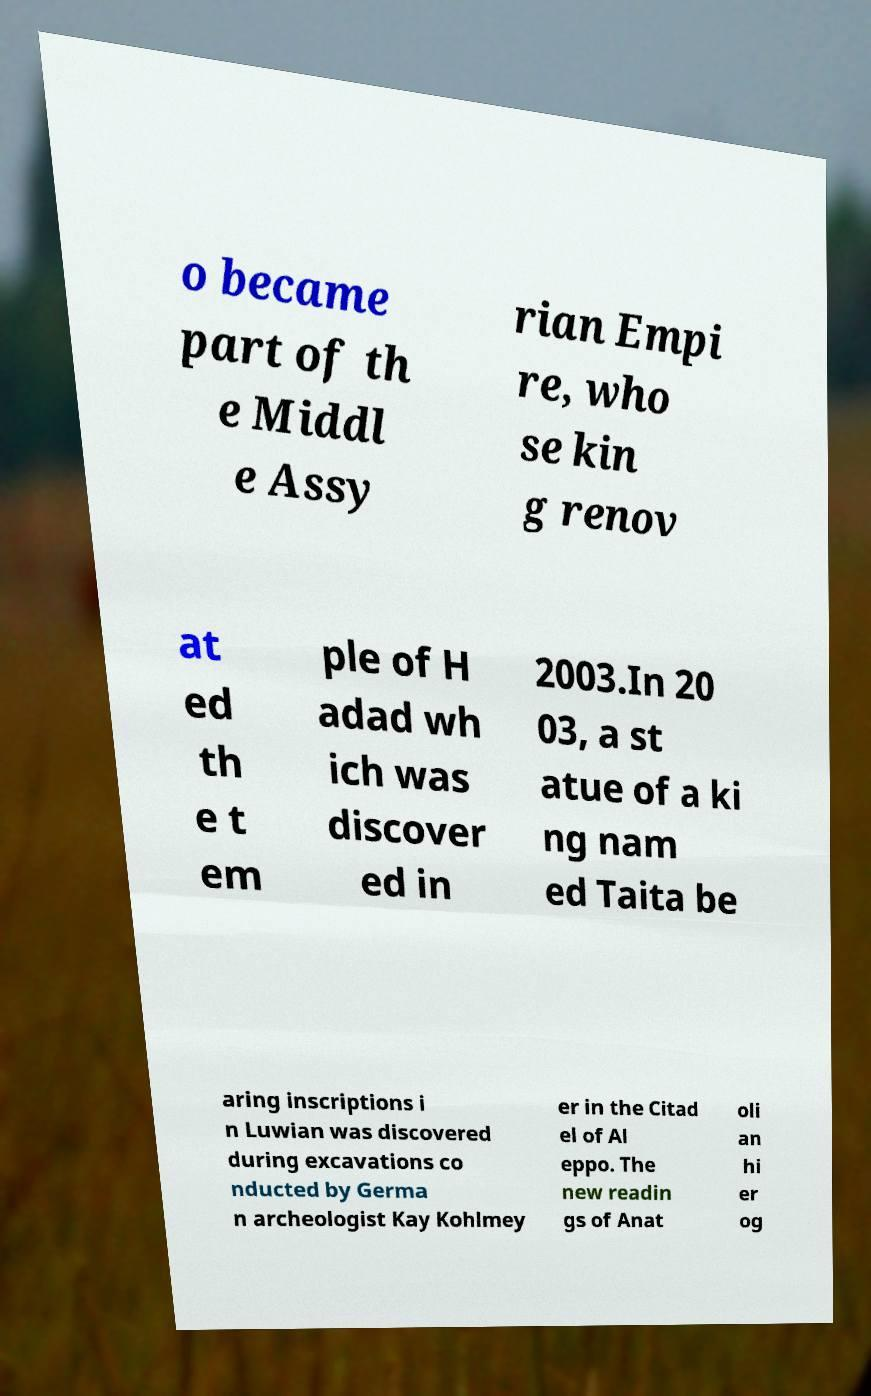There's text embedded in this image that I need extracted. Can you transcribe it verbatim? o became part of th e Middl e Assy rian Empi re, who se kin g renov at ed th e t em ple of H adad wh ich was discover ed in 2003.In 20 03, a st atue of a ki ng nam ed Taita be aring inscriptions i n Luwian was discovered during excavations co nducted by Germa n archeologist Kay Kohlmey er in the Citad el of Al eppo. The new readin gs of Anat oli an hi er og 